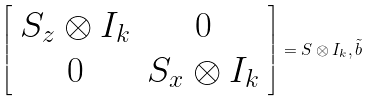<formula> <loc_0><loc_0><loc_500><loc_500>\left [ \begin{array} { c c } S _ { z } \otimes I _ { k } & 0 \\ 0 & S _ { x } \otimes I _ { k } \end{array} \right ] = S \otimes I _ { k } , \tilde { b }</formula> 